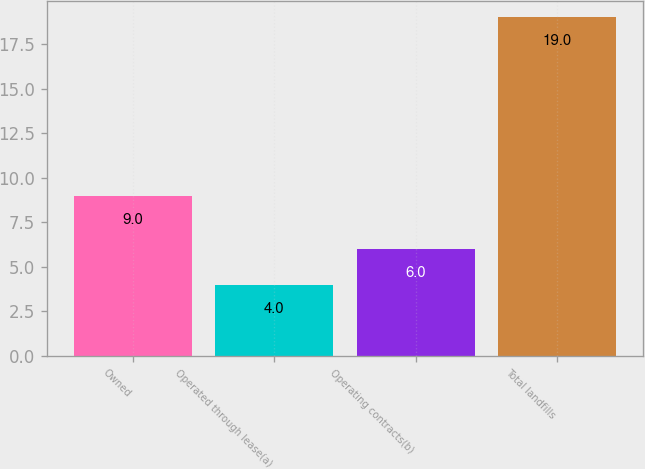Convert chart to OTSL. <chart><loc_0><loc_0><loc_500><loc_500><bar_chart><fcel>Owned<fcel>Operated through lease(a)<fcel>Operating contracts(b)<fcel>Total landfills<nl><fcel>9<fcel>4<fcel>6<fcel>19<nl></chart> 